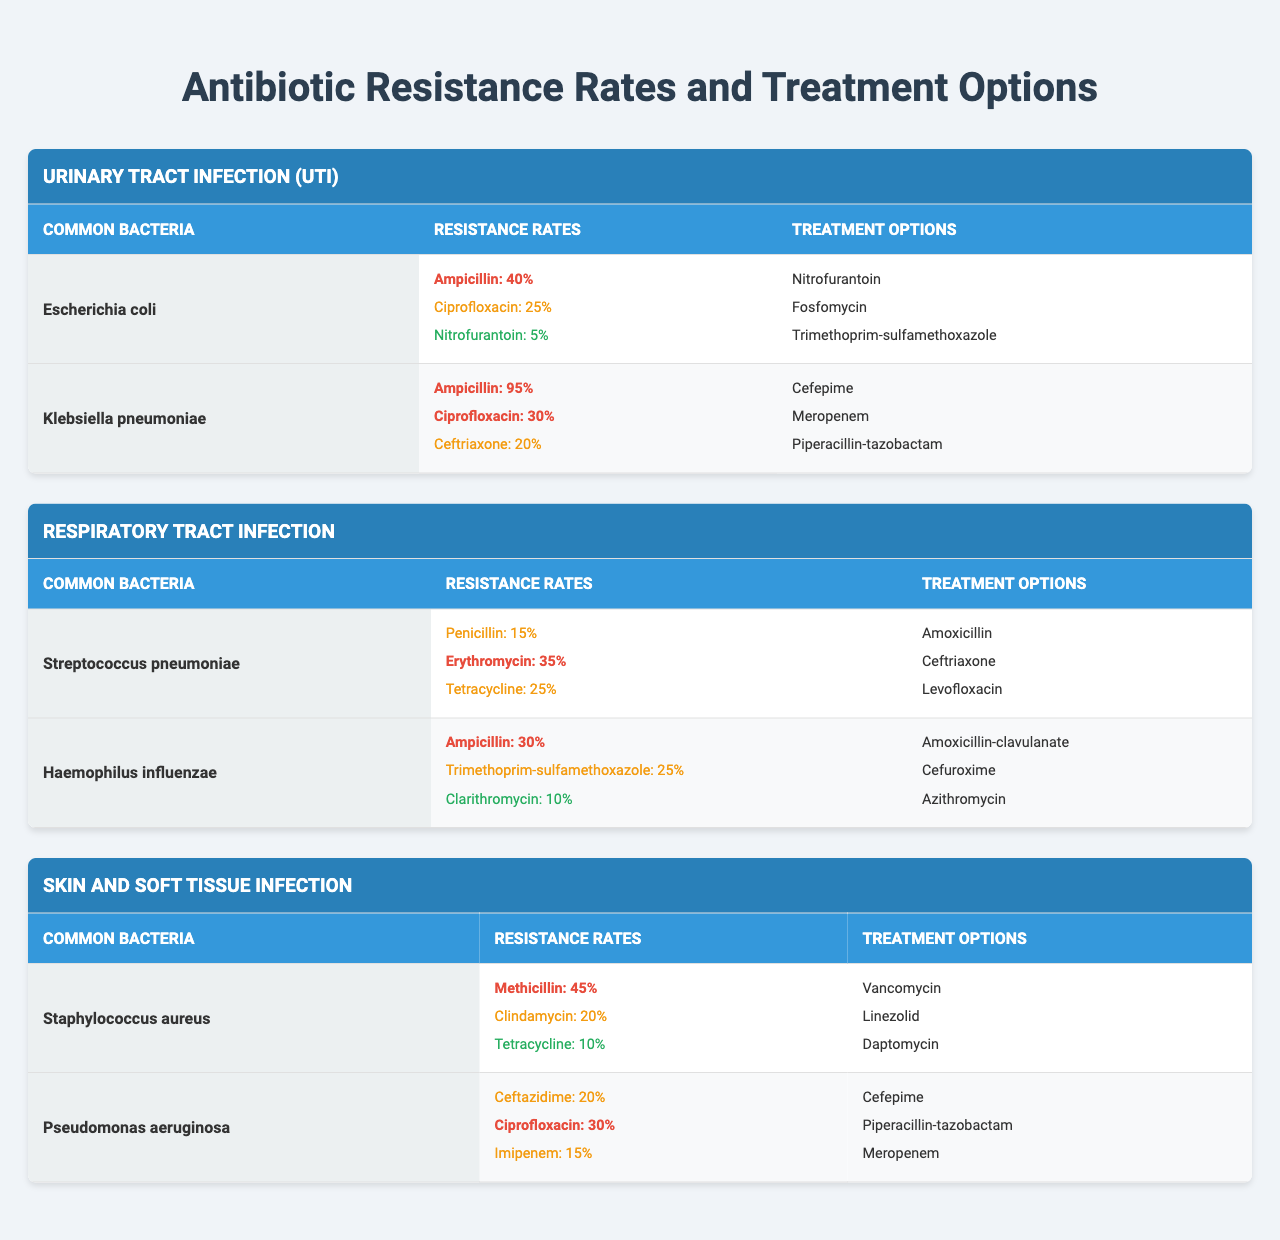What are the most resistant common bacteria for Urinary Tract Infections? The table for Urinary Tract Infections shows two common bacteria: Escherichia coli and Klebsiella pneumoniae. By comparing their resistance rates for the listed antibiotics, Klebsiella pneumoniae has a high resistance rate of 95% for Ampicillin, making it the most resistant.
Answer: Klebsiella pneumoniae What antibiotic has the lowest resistance rate for Escherichia coli? The resistance rates for Escherichia coli are 40% for Ampicillin, 25% for Ciprofloxacin, and 5% for Nitrofurantoin. The lowest among these is 5% for Nitrofurantoin.
Answer: Nitrofurantoin Do all bacteria listed for Skin and Soft Tissue Infections have a resistance rate above 20% for Methicillin? Staphylococcus aureus has a resistance rate of 45% for Methicillin, but Pseudomonas aeruginosa does not include Methicillin in its resistance rates. So, it's not applicable for all listed bacteria.
Answer: No Which antibiotic had the highest resistance rate across all bacteria listed in the table? To find the antibiotic with the highest resistance rate, we examine all provided rates: the highest is 95% for Ampicillin with Klebsiella pneumoniae, higher than any other listed resistance rates for other antibiotics and bacteria.
Answer: Ampicillin What is the average resistance rate for Ciprofloxacin among the common bacteria listed? The resistance rate for Ciprofloxacin is 25% for Escherichia coli and 30% for Pseudomonas aeruginosa. To calculate the average, we sum the rates (25 + 30 = 55) and divide by the number of bacteria (2). Therefore, the average is 55/2 = 27.5%.
Answer: 27.5% Which infection has bacteria with the highest overall resistance rates? Reviewing the infections and their associated bacteria, Klebsiella pneumoniae shows the highest resistance for Ampicillin (95%) and a relatively high rate for Ciprofloxacin (30%). Compared to other infections, UTI has the highest resistance rates overall due to the presence of Klebsiella pneumoniae.
Answer: Urinary Tract Infection What are the treatment options for Haemophilus influenzae? The table lists three treatment options for Haemophilus influenzae: Amoxicillin-clavulanate, Cefuroxime, and Azithromycin.
Answer: Amoxicillin-clavulanate, Cefuroxime, Azithromycin Is the resistance rate for Tetracycline in Staphylococcus aureus lower than that in Streptococcus pneumoniae? Staphylococcus aureus has a resistance rate of 10% for Tetracycline, while Streptococcus pneumoniae has a resistance rate of 25%. Hence, 10% is lower than 25%.
Answer: Yes Which bacteria associated with Respiratory Tract Infections has the highest resistance to Erythromycin? Streptococcus pneumoniae has a resistance rate of 35% for Erythromycin, which is the highest among the bacteria associated with Respiratory Tract Infections in the table.
Answer: Streptococcus pneumoniae For Pseudomonas aeruginosa, what is the combined resistance rate for Ceftazidime and Ciprofloxacin? The resistance rate for Ceftazidime is 20% and for Ciprofloxacin is 30%. Adding these gives a combined resistance rate of (20 + 30 = 50)%.
Answer: 50% 